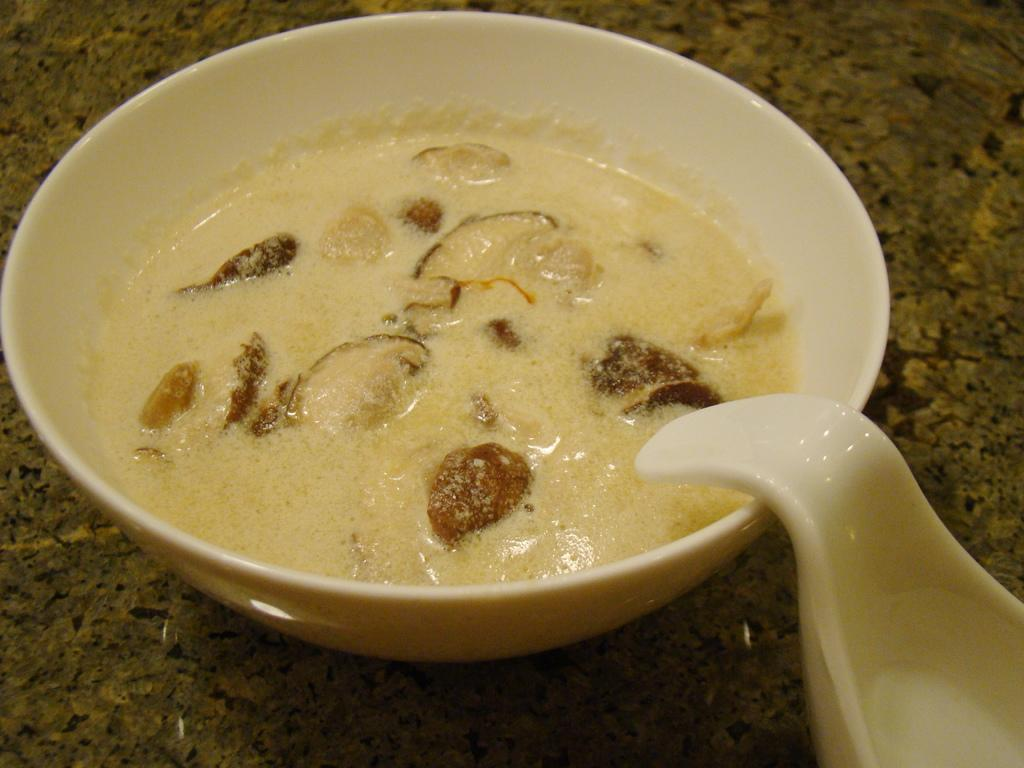What is in the bowl that is visible in the image? There is a bowl in the image, and it contains desert. What utensil is located beside the bowl? There is a spoon beside the bowl on the right side bottom. What type of texture can be seen on the underwear in the image? There is no underwear present in the image, so it is not possible to determine the texture. 